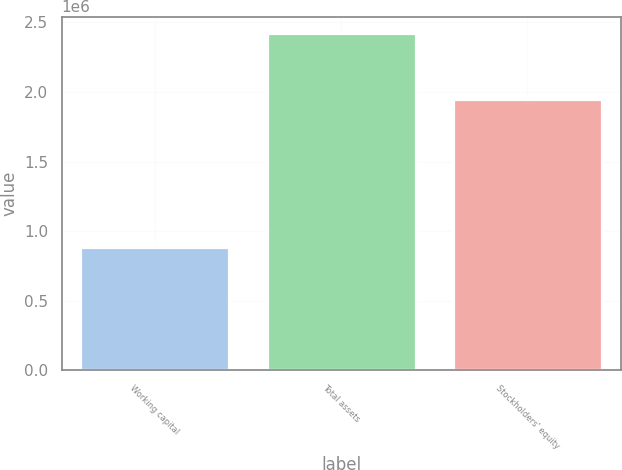<chart> <loc_0><loc_0><loc_500><loc_500><bar_chart><fcel>Working capital<fcel>Total assets<fcel>Stockholders' equity<nl><fcel>883322<fcel>2.42168e+06<fcel>1.95074e+06<nl></chart> 